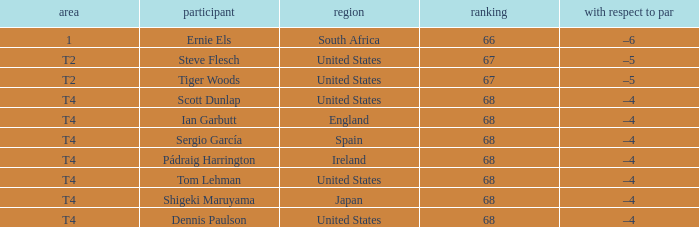What is the Place of the Player with a Score of 67? T2, T2. 